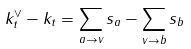<formula> <loc_0><loc_0><loc_500><loc_500>k ^ { \vee } _ { t } - k _ { t } = \sum _ { a \to v } s _ { a } - \sum _ { v \to b } s _ { b }</formula> 